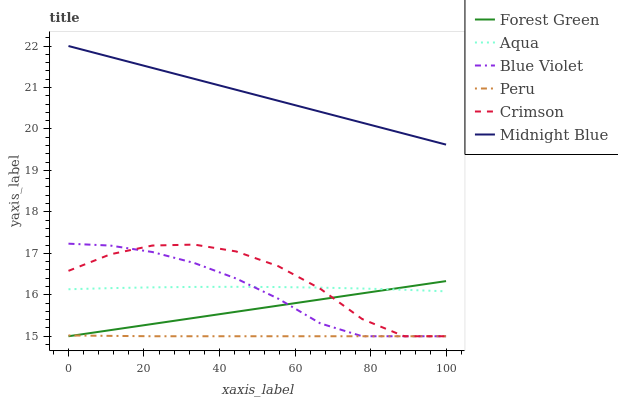Does Aqua have the minimum area under the curve?
Answer yes or no. No. Does Aqua have the maximum area under the curve?
Answer yes or no. No. Is Aqua the smoothest?
Answer yes or no. No. Is Aqua the roughest?
Answer yes or no. No. Does Aqua have the lowest value?
Answer yes or no. No. Does Aqua have the highest value?
Answer yes or no. No. Is Crimson less than Midnight Blue?
Answer yes or no. Yes. Is Aqua greater than Peru?
Answer yes or no. Yes. Does Crimson intersect Midnight Blue?
Answer yes or no. No. 